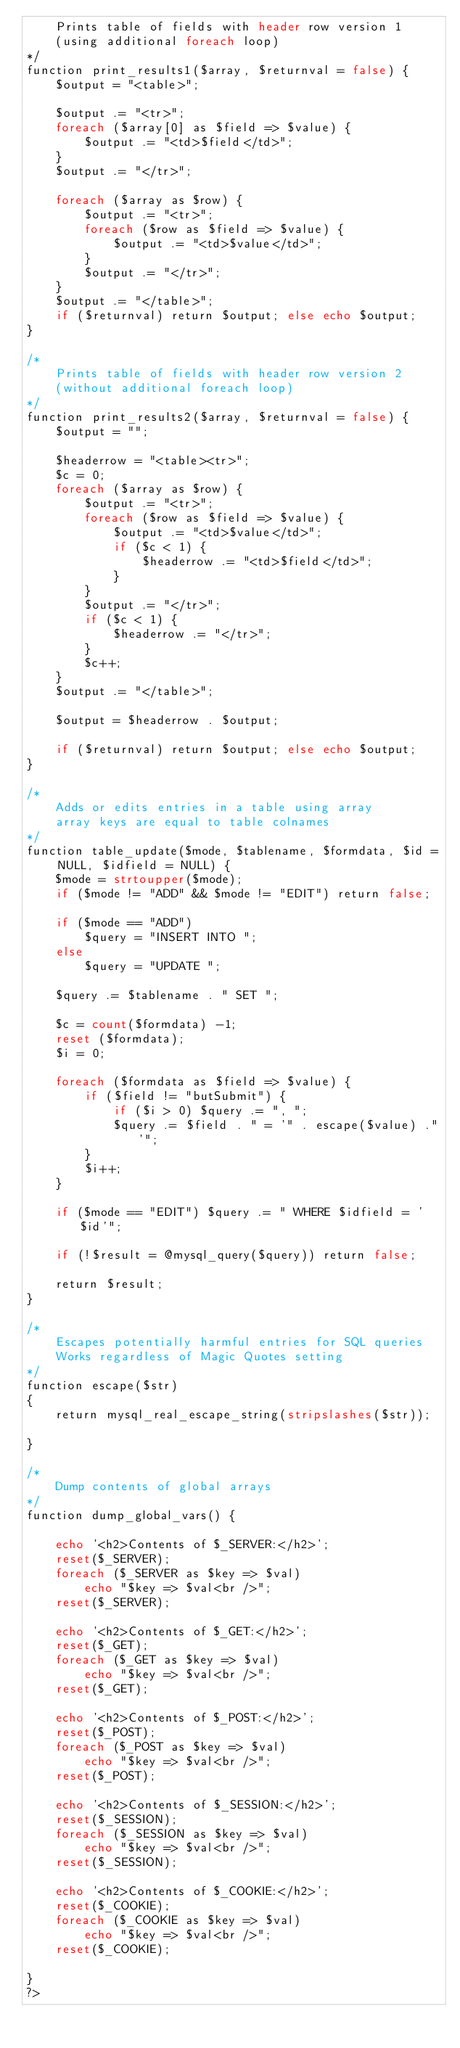Convert code to text. <code><loc_0><loc_0><loc_500><loc_500><_PHP_>	Prints table of fields with header row version 1
	(using additional foreach loop)
*/
function print_results1($array, $returnval = false) {
	$output = "<table>";

	$output .= "<tr>";
	foreach ($array[0] as $field => $value) {
		$output .= "<td>$field</td>";
	}
	$output .= "</tr>";
	
	foreach ($array as $row) {
		$output .= "<tr>";
		foreach ($row as $field => $value) {
			$output .= "<td>$value</td>";
		}
		$output .= "</tr>";
	}
	$output .= "</table>";
	if ($returnval) return $output; else echo $output;
}

/*
	Prints table of fields with header row version 2
	(without additional foreach loop)
*/
function print_results2($array, $returnval = false) {
	$output = "";

	$headerrow = "<table><tr>";
	$c = 0;
	foreach ($array as $row) {
		$output .= "<tr>";
		foreach ($row as $field => $value) {
			$output .= "<td>$value</td>";
			if ($c < 1) {
				$headerrow .= "<td>$field</td>";
			}
		}
		$output .= "</tr>";
		if ($c < 1) {
			$headerrow .= "</tr>";
		}
		$c++;
	}
	$output .= "</table>";

	$output = $headerrow . $output;
	
	if ($returnval) return $output; else echo $output;
}

/*
	Adds or edits entries in a table using array
	array keys are equal to table colnames
*/
function table_update($mode, $tablename, $formdata, $id = NULL, $idfield = NULL) {
	$mode = strtoupper($mode);
	if ($mode != "ADD" && $mode != "EDIT") return false;
	
	if ($mode == "ADD")
		$query = "INSERT INTO ";
	else
		$query = "UPDATE ";
		
	$query .= $tablename . " SET ";
	
	$c = count($formdata) -1;
	reset ($formdata);
	$i = 0;
	
	foreach ($formdata as $field => $value) {
		if ($field != "butSubmit") {
			if ($i > 0) $query .= ", ";
			$query .= $field . " = '" . escape($value) ."'";
		}
		$i++;
	}
	
	if ($mode == "EDIT") $query .= " WHERE $idfield = '$id'";
	
	if (!$result = @mysql_query($query)) return false;
	
	return $result;
}

/*
	Escapes potentially harmful entries for SQL queries
	Works regardless of Magic Quotes setting
*/
function escape($str)
{
	return mysql_real_escape_string(stripslashes($str));				
}

/*
	Dump contents of global arrays
*/
function dump_global_vars() {

	echo '<h2>Contents of $_SERVER:</h2>';
	reset($_SERVER);
	foreach ($_SERVER as $key => $val)
		echo "$key => $val<br />";
	reset($_SERVER);

	echo '<h2>Contents of $_GET:</h2>';
	reset($_GET);
	foreach ($_GET as $key => $val)
		echo "$key => $val<br />";
	reset($_GET);

	echo '<h2>Contents of $_POST:</h2>';
	reset($_POST);
	foreach ($_POST as $key => $val)
		echo "$key => $val<br />";
	reset($_POST);

	echo '<h2>Contents of $_SESSION:</h2>';
	reset($_SESSION);
	foreach ($_SESSION as $key => $val)
		echo "$key => $val<br />";
	reset($_SESSION);

	echo '<h2>Contents of $_COOKIE:</h2>';
	reset($_COOKIE);
	foreach ($_COOKIE as $key => $val)
		echo "$key => $val<br />";
	reset($_COOKIE);
	
}
?></code> 